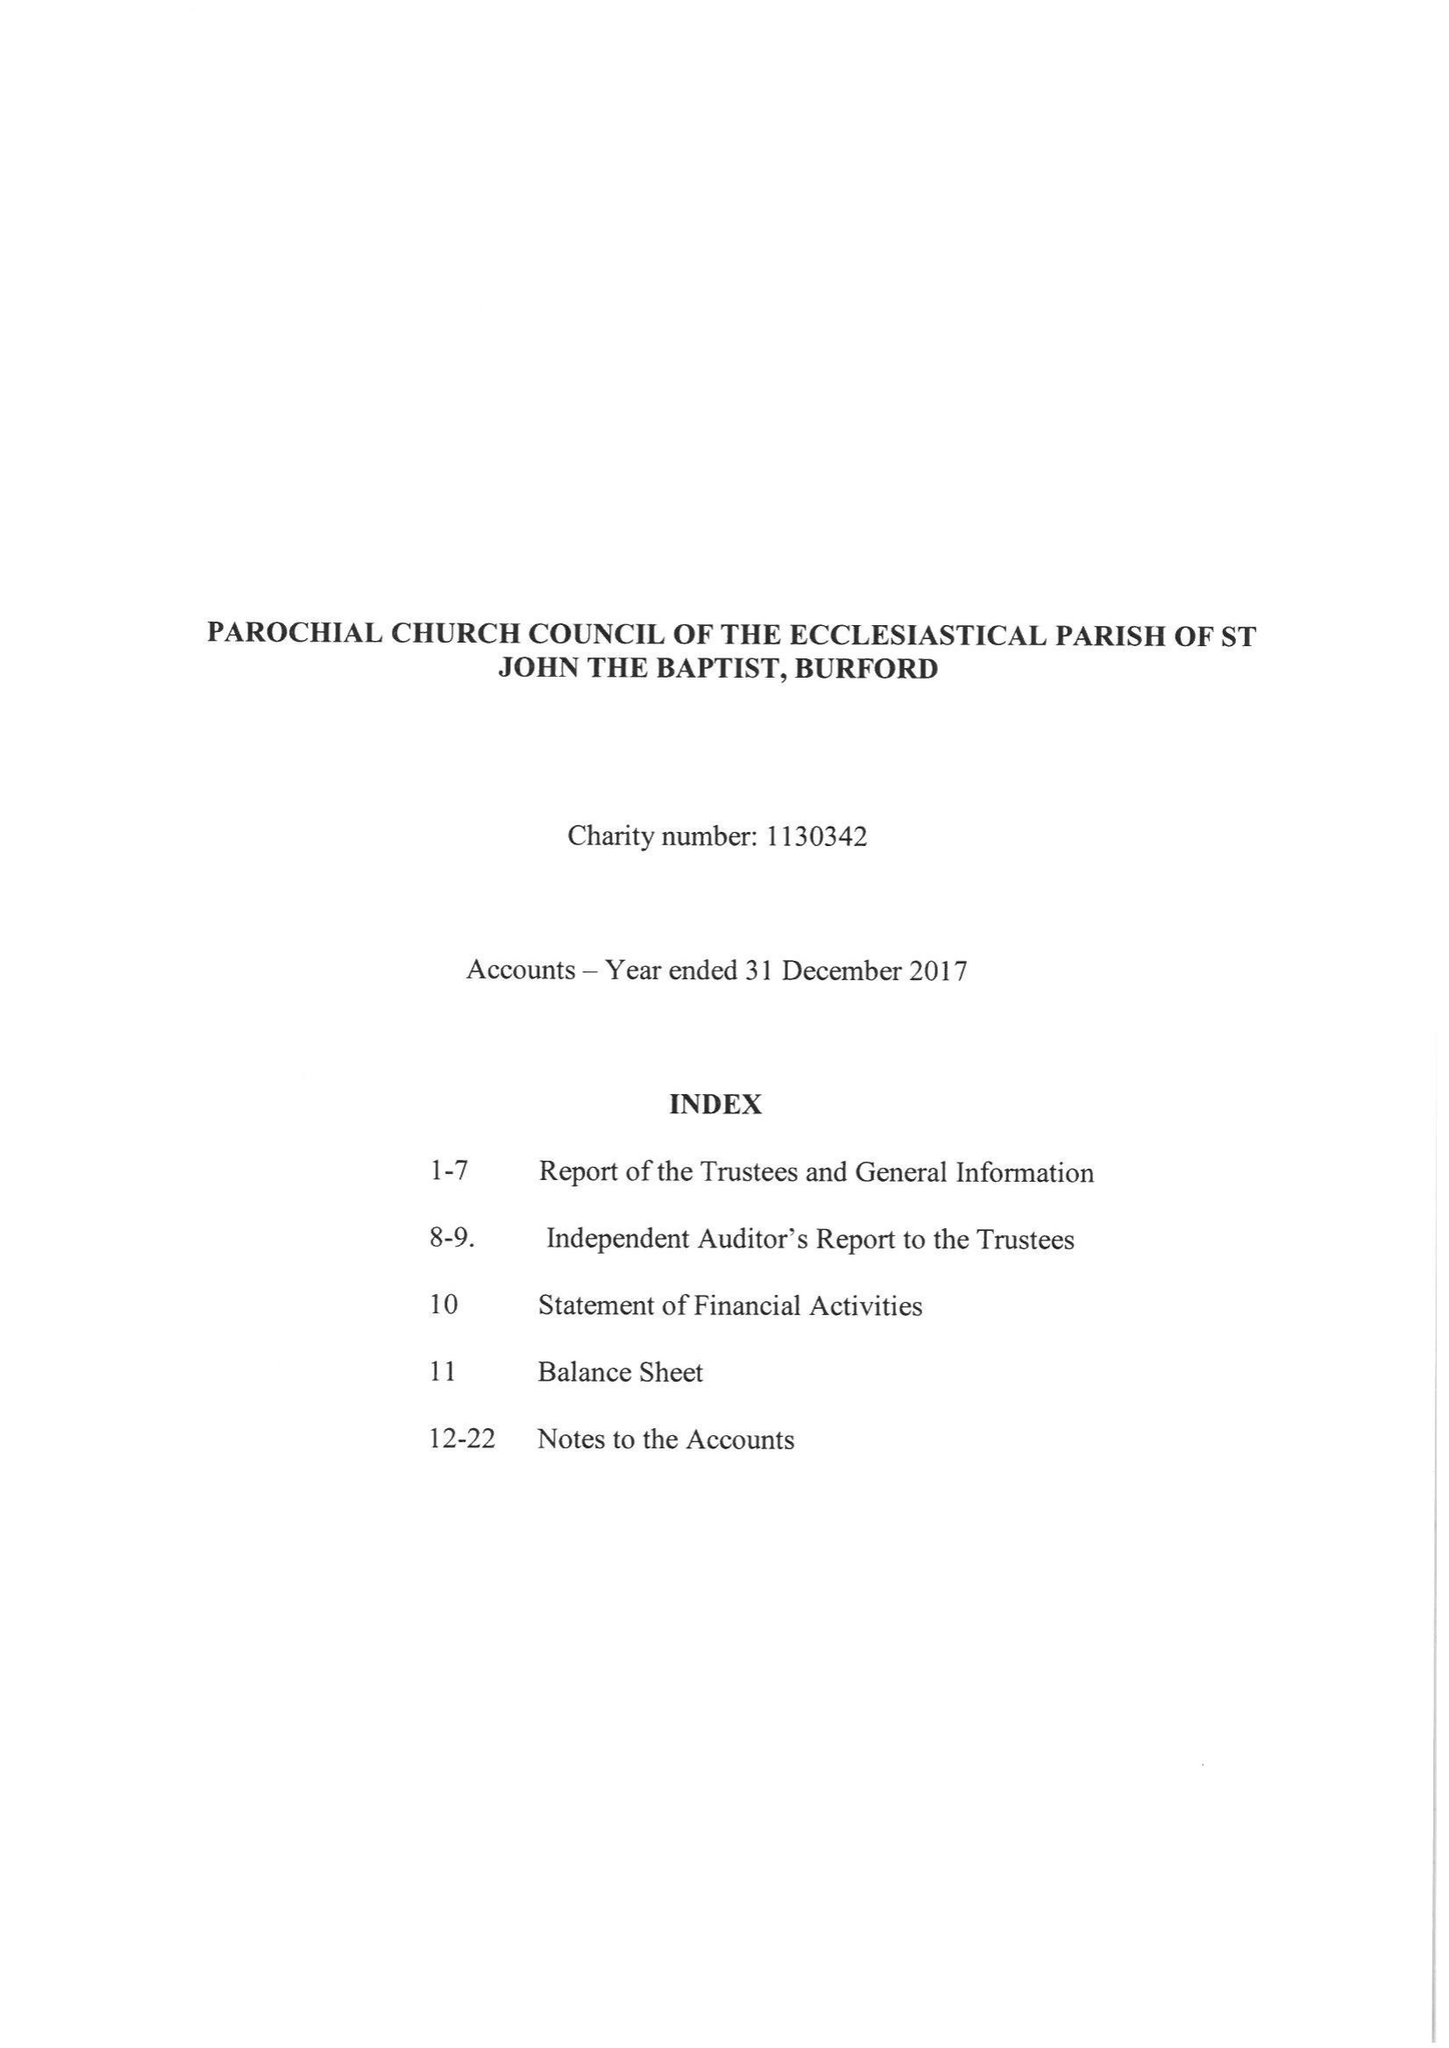What is the value for the income_annually_in_british_pounds?
Answer the question using a single word or phrase. 483447.00 